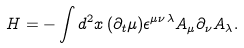<formula> <loc_0><loc_0><loc_500><loc_500>H = - \int d ^ { 2 } { x } \, ( \partial _ { t } \mu ) \epsilon ^ { \mu \nu \lambda } A _ { \mu } \partial _ { \nu } A _ { \lambda } .</formula> 